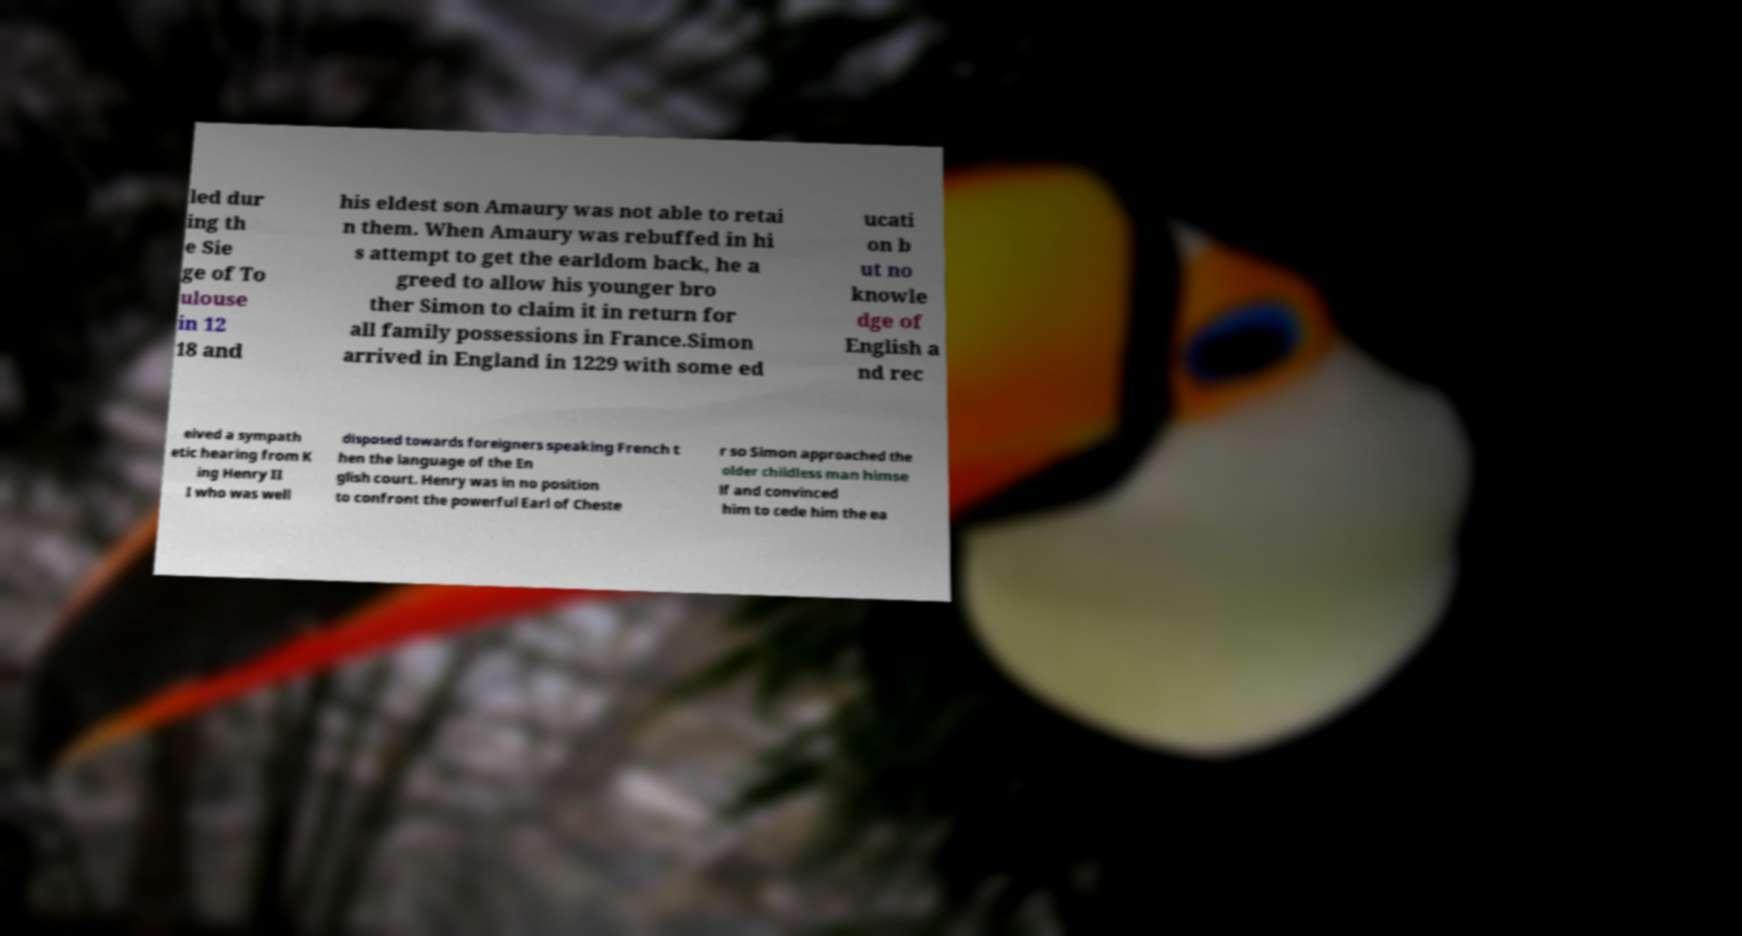Please read and relay the text visible in this image. What does it say? led dur ing th e Sie ge of To ulouse in 12 18 and his eldest son Amaury was not able to retai n them. When Amaury was rebuffed in hi s attempt to get the earldom back, he a greed to allow his younger bro ther Simon to claim it in return for all family possessions in France.Simon arrived in England in 1229 with some ed ucati on b ut no knowle dge of English a nd rec eived a sympath etic hearing from K ing Henry II I who was well disposed towards foreigners speaking French t hen the language of the En glish court. Henry was in no position to confront the powerful Earl of Cheste r so Simon approached the older childless man himse lf and convinced him to cede him the ea 